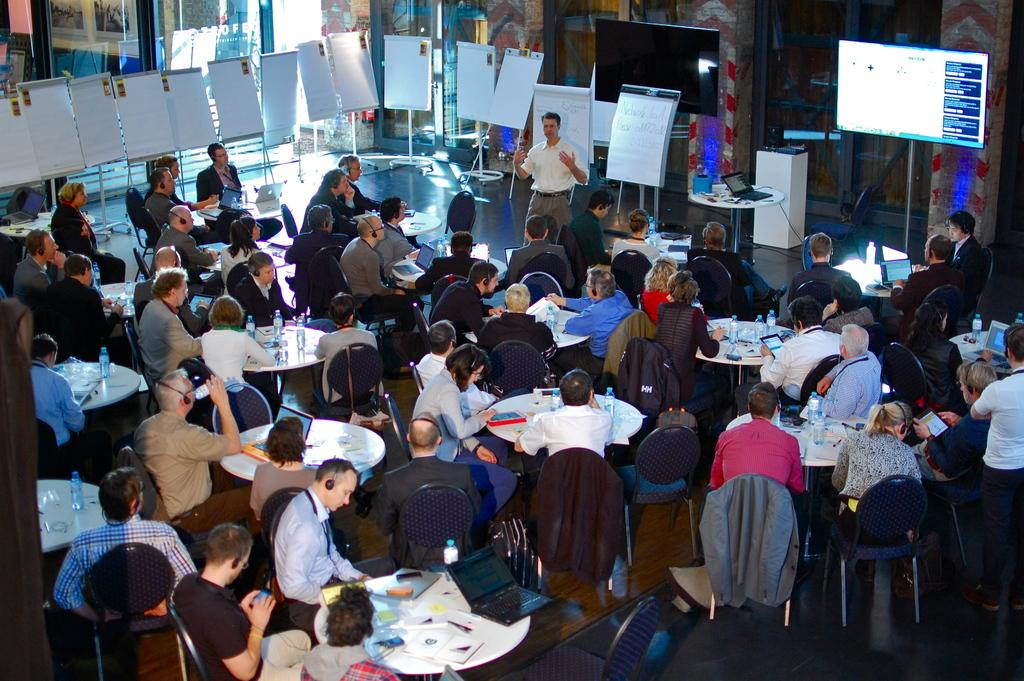How many people are in the image? There is a group of people in the image. What are the people doing in the image? The people are sitting in chairs. Where are the chairs located in relation to the table? The chairs are near a table. What electronic devices can be seen in the background of the image? There is a laptop and a television in the background. What type of signage is visible in the background? There is a hoarding in the background. What type of balls are being used for the cushion in the image? There are no balls or cushions present in the image. 